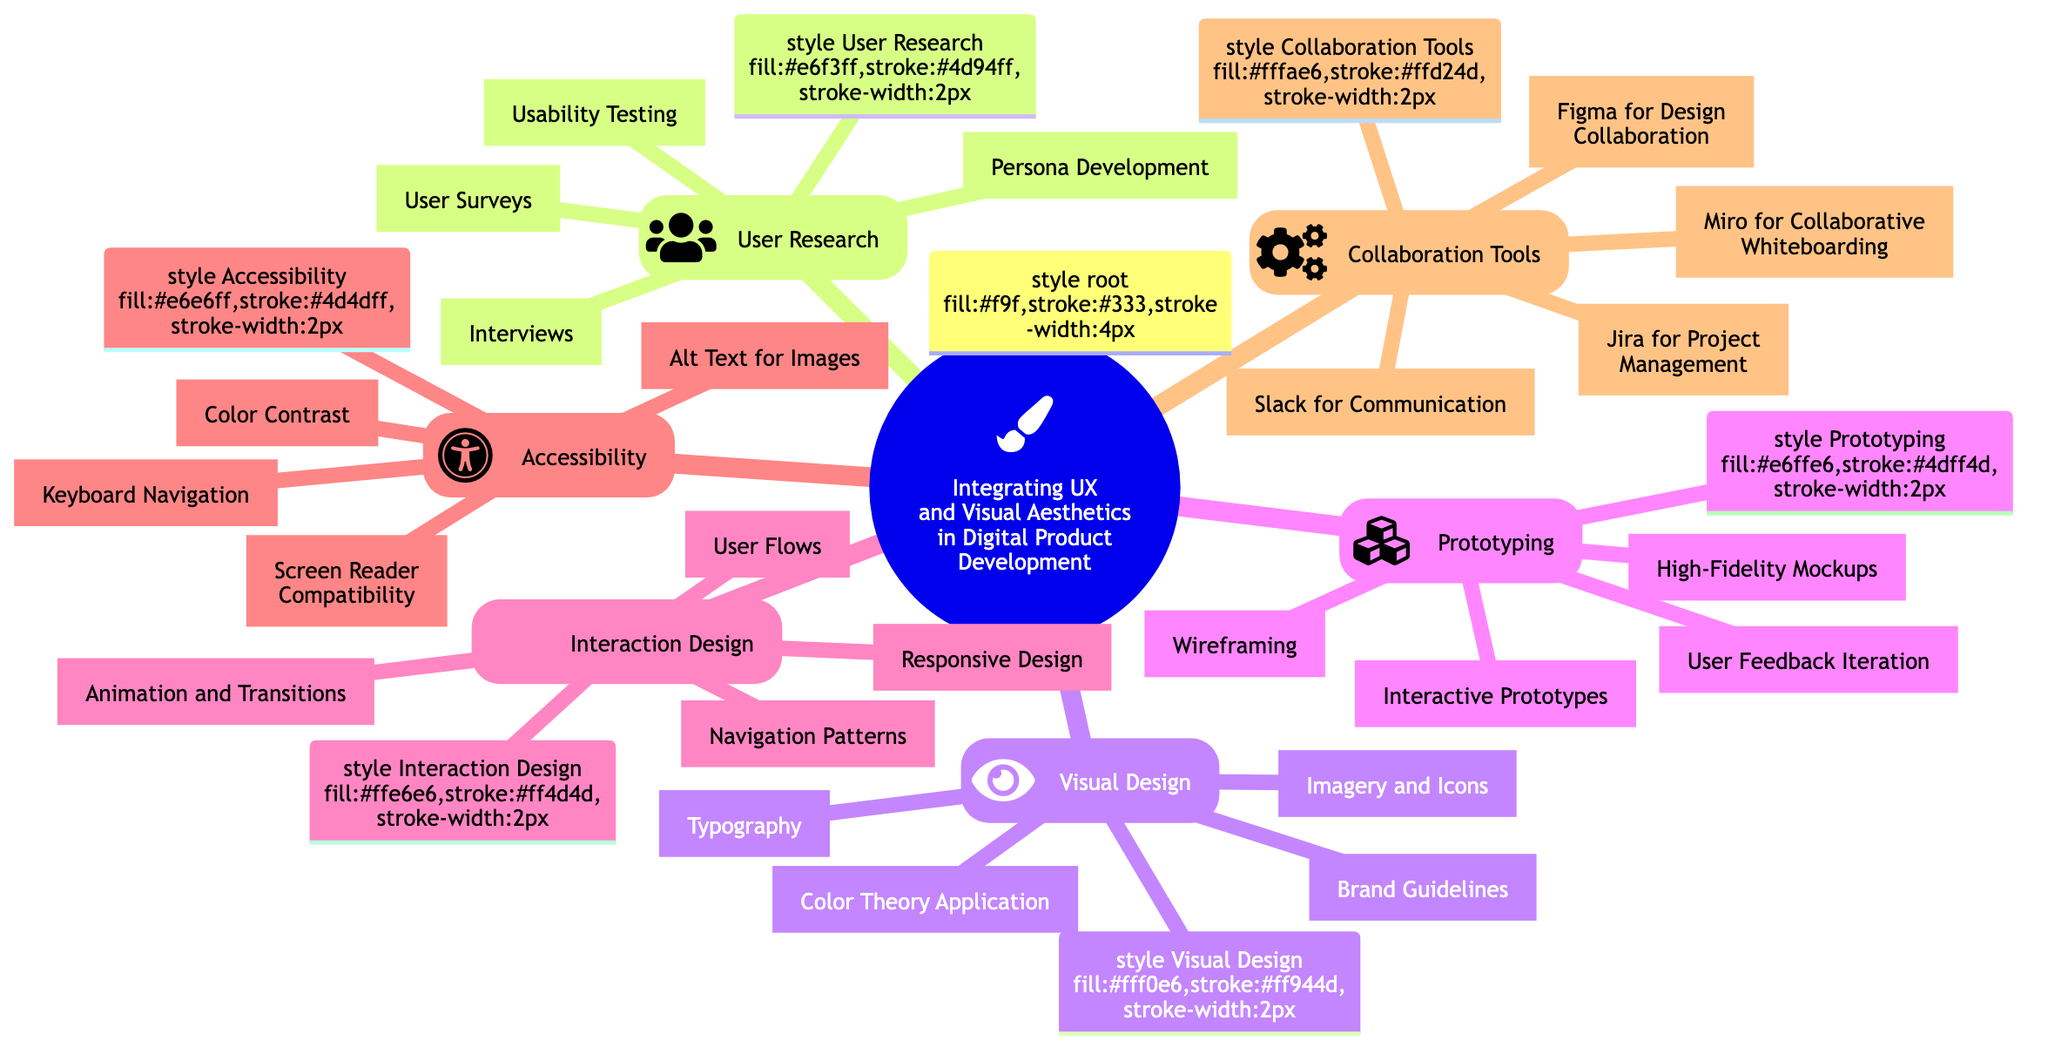What are the sub-elements under User Research? The diagram specifies that User Research includes four sub-elements: User Surveys, Interviews, Usability Testing, and Persona Development. These elements are directly listed beneath the User Research node.
Answer: User Surveys, Interviews, Usability Testing, Persona Development How many sub-elements are listed under Visual Design? In the diagram, Visual Design has four sub-elements. These are shown under the Visual Design node, confirming that there are four in total.
Answer: Four What element focuses on Accessibility? The diagram highlights Accessibility as a separate element that includes four sub-elements related to making designs accessible to all users. This is explicitly listed in the concept map.
Answer: Accessibility Which collaboration tool is specifically mentioned for design collaboration? The diagram lists Figma under Collaboration Tools as a specific tool for design collaboration, indicated by its presence under this category.
Answer: Figma What is the relationship between Prototyping and User Feedback Iteration? User Feedback Iteration is one of the sub-elements of Prototyping, meaning it is a component that contributes to the overall prototyping process by incorporating user feedback to improve designs.
Answer: Sub-element How many different elements are there in total? The diagram includes five main elements: User Research, Visual Design, Prototyping, Interaction Design, and Accessibility, plus Collaboration Tools, leading to a count of six distinct elements overall.
Answer: Six What might be a primary goal of Interaction Design? The main focus of Interaction Design as indicated in the diagram centers around creating effective User Flows and Navigation Patterns, enhancing user interaction with the product, although this is conceptually implied rather than explicitly stated.
Answer: Improving user interaction What does the node representing Accessibility emphasize? The Accessibility node in the diagram emphasizes the importance of inclusive design practices, which is articulated through its four specific sub-elements that address various accessibility standards.
Answer: Inclusive design practices Which sub-element involves User Surveys? The sub-element that involves User Surveys is found under User Research, indicating its role in gathering user insights which is necessary for understanding user needs.
Answer: User Research 